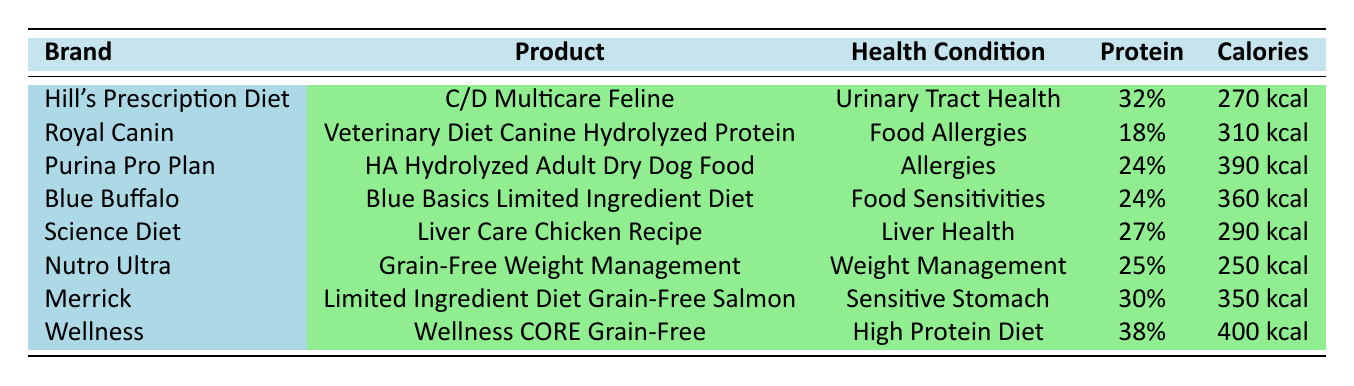What brand offers a product for Urinary Tract Health? Looking at the table, under the "Health Condition" column, the entry for "Urinary Tract Health" corresponds to the brand "Hill's Prescription Diet" with the product "C/D Multicare Feline."
Answer: Hill's Prescription Diet Which product has the highest protein content? Reviewing the table, "Wellness CORE Grain-Free" has the highest protein content listed at 38%.
Answer: Wellness CORE Grain-Free What is the caloric content of the "Grain-Free Weight Management" product? In the "Health Condition" column, "Weight Management" corresponds to "Nutro Ultra," which shows a caloric content of "250 kcal."
Answer: 250 kcal Is there a product listed for Food Sensitivities? The table shows that "Blue Buffalo" has a product named "Blue Basics Limited Ingredient Diet" specifically for Food Sensitivities.
Answer: Yes What is the difference in protein content between the "C/D Multicare Feline" and "Liver Care Chicken Recipe"? The protein content for "C/D Multicare Feline" is 32%, and for "Liver Care Chicken Recipe," it is 27%. The difference is 32% - 27% = 5%.
Answer: 5% Which product has a higher caloric content: "Limited Ingredient Diet Grain-Free Salmon" or "Wellness CORE Grain-Free"? The caloric content of "Limited Ingredient Diet Grain-Free Salmon" is 350 kcal and that of "Wellness CORE Grain-Free" is 400 kcal. Comparing these values, 400 kcal is higher than 350 kcal.
Answer: Wellness CORE Grain-Free What is the average protein content of the products listed for allergies/sensitivities? The products for allergies/sensitivities are "Veterinary Diet Canine Hydrolyzed Protein" with 18% protein, "HA Hydrolyzed Adult Dry Dog Food" with 24%, and "Limited Ingredient Diet Grain-Free Salmon" with 30%. The average is (18% + 24% + 30%) / 3 = 24%.
Answer: 24% Which product has the lowest fat content and what is it? Scanning the fat content, the product "Liver Care Chicken Recipe" has the lowest fat content listed at 9%.
Answer: 9% How many products contain fish as an additional ingredient? Examining the additional ingredients, "Veterinary Diet Canine Hydrolyzed Protein" contains "Fish Oil," and "Limited Ingredient Diet Grain-Free Salmon" contains "Salmon." So, there are 2 products.
Answer: 2 Which pet food product is intended for weight management and how much protein does it contain? The product for weight management is "Nutro Ultra" with a protein content of 25%.
Answer: 25% 